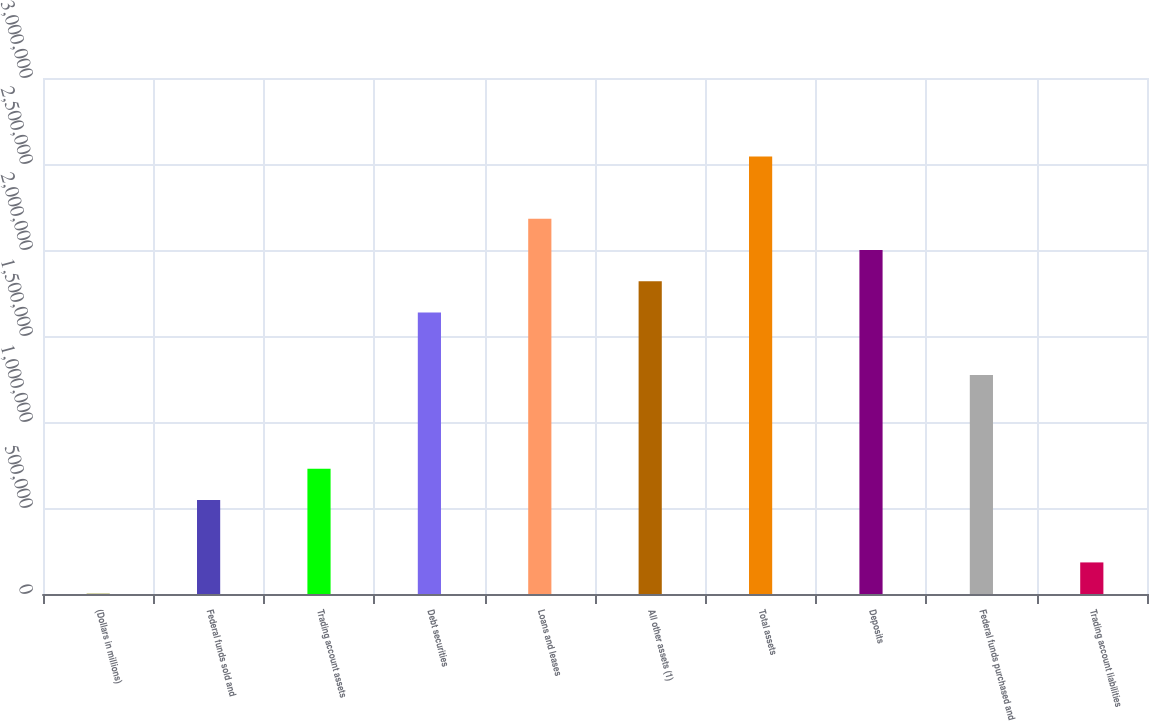Convert chart. <chart><loc_0><loc_0><loc_500><loc_500><bar_chart><fcel>(Dollars in millions)<fcel>Federal funds sold and<fcel>Trading account assets<fcel>Debt securities<fcel>Loans and leases<fcel>All other assets (1)<fcel>Total assets<fcel>Deposits<fcel>Federal funds purchased and<fcel>Trading account liabilities<nl><fcel>2008<fcel>546788<fcel>728382<fcel>1.63635e+06<fcel>2.18113e+06<fcel>1.81794e+06<fcel>2.54432e+06<fcel>1.99954e+06<fcel>1.27316e+06<fcel>183602<nl></chart> 